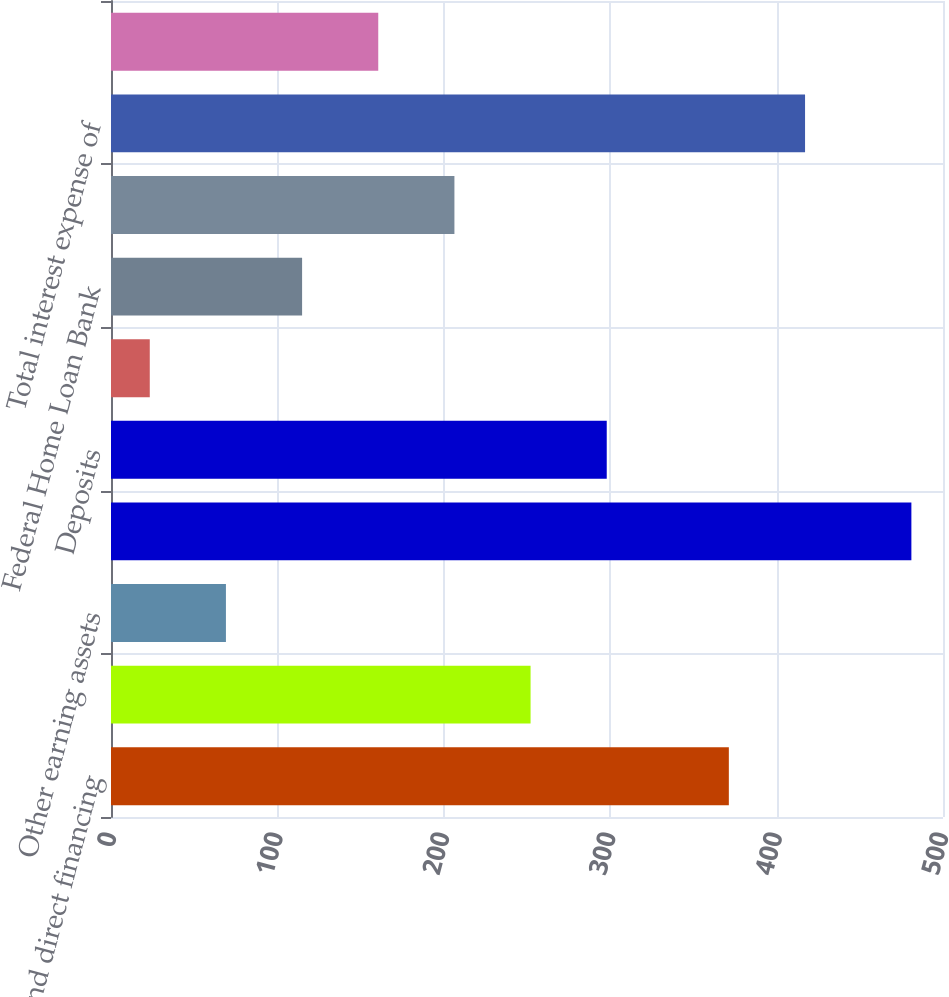Convert chart to OTSL. <chart><loc_0><loc_0><loc_500><loc_500><bar_chart><fcel>Loans and direct financing<fcel>Investment securities<fcel>Other earning assets<fcel>Total interest income from<fcel>Deposits<fcel>Short-term borrowings<fcel>Federal Home Loan Bank<fcel>Subordinated notes and other<fcel>Total interest expense of<fcel>Net interest income<nl><fcel>371.3<fcel>252.15<fcel>69.07<fcel>481<fcel>297.92<fcel>23.3<fcel>114.84<fcel>206.38<fcel>417.1<fcel>160.61<nl></chart> 